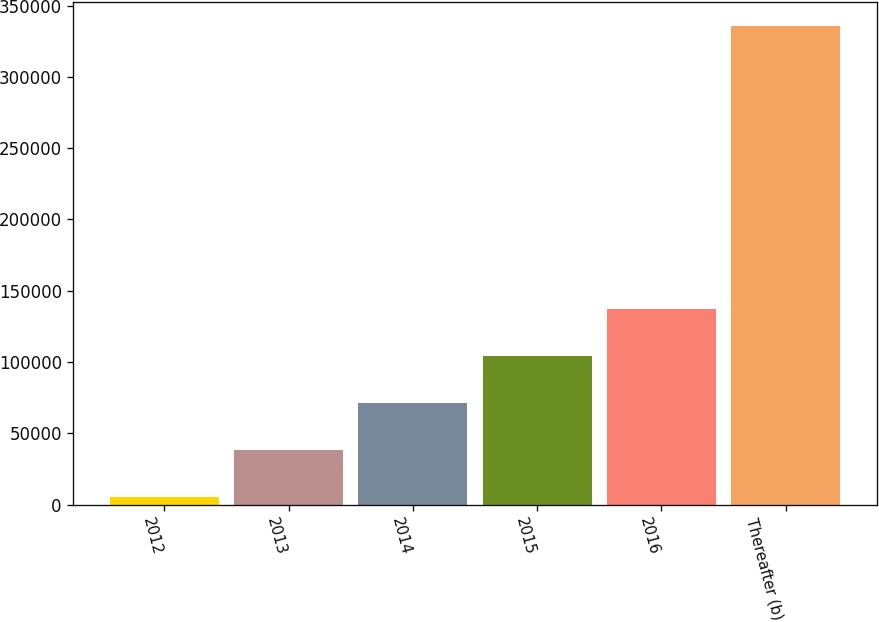Convert chart. <chart><loc_0><loc_0><loc_500><loc_500><bar_chart><fcel>2012<fcel>2013<fcel>2014<fcel>2015<fcel>2016<fcel>Thereafter (b)<nl><fcel>5193<fcel>38245<fcel>71297<fcel>104349<fcel>137401<fcel>335713<nl></chart> 